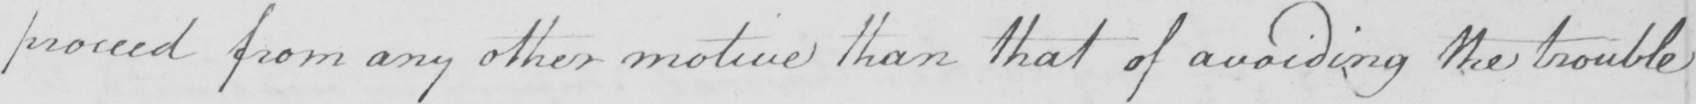Can you tell me what this handwritten text says? proved from any other motive than that of avoiding the trouble 